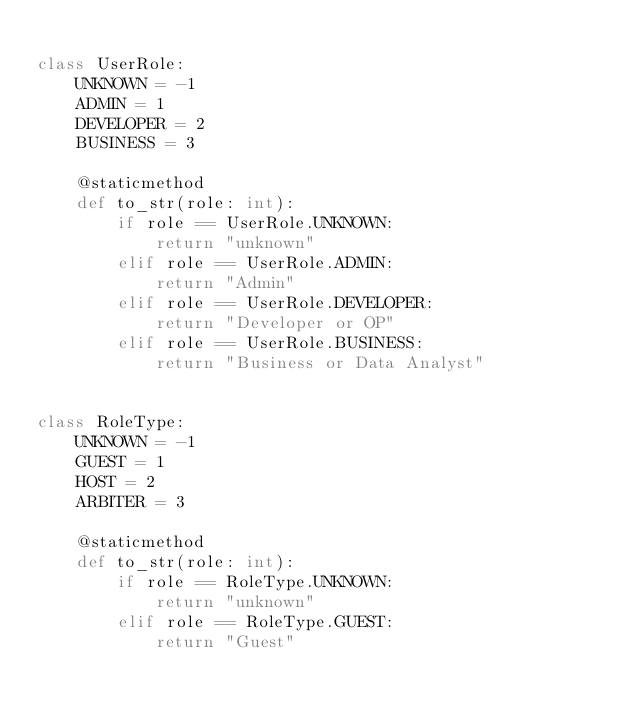Convert code to text. <code><loc_0><loc_0><loc_500><loc_500><_Python_>
class UserRole:
    UNKNOWN = -1
    ADMIN = 1
    DEVELOPER = 2
    BUSINESS = 3

    @staticmethod
    def to_str(role: int):
        if role == UserRole.UNKNOWN:
            return "unknown"
        elif role == UserRole.ADMIN:
            return "Admin"
        elif role == UserRole.DEVELOPER:
            return "Developer or OP"
        elif role == UserRole.BUSINESS:
            return "Business or Data Analyst"


class RoleType:
    UNKNOWN = -1
    GUEST = 1
    HOST = 2
    ARBITER = 3

    @staticmethod
    def to_str(role: int):
        if role == RoleType.UNKNOWN:
            return "unknown"
        elif role == RoleType.GUEST:
            return "Guest"</code> 